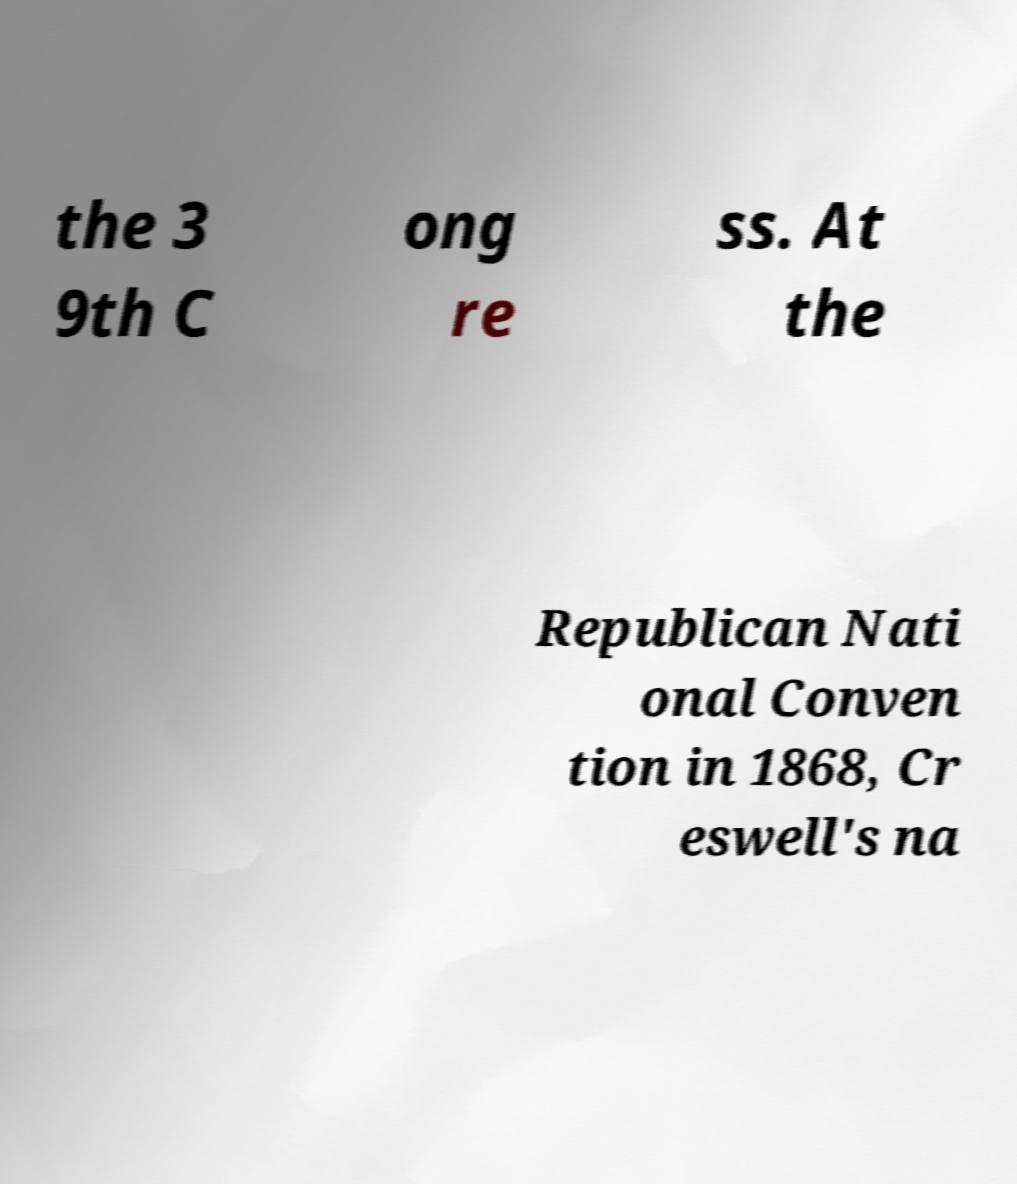Please identify and transcribe the text found in this image. the 3 9th C ong re ss. At the Republican Nati onal Conven tion in 1868, Cr eswell's na 